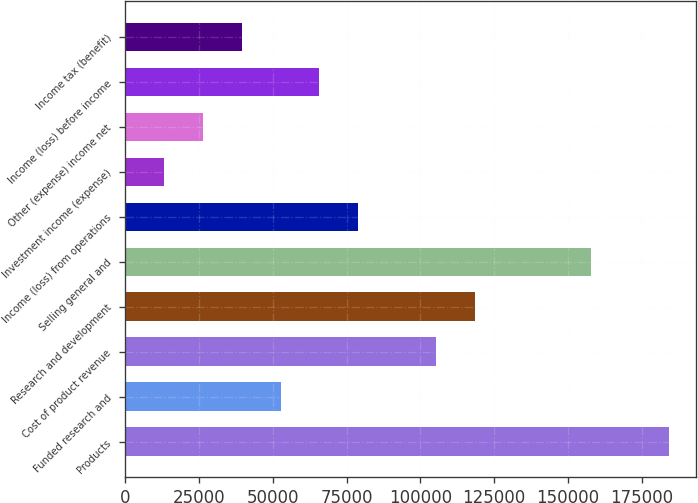Convert chart. <chart><loc_0><loc_0><loc_500><loc_500><bar_chart><fcel>Products<fcel>Funded research and<fcel>Cost of product revenue<fcel>Research and development<fcel>Selling general and<fcel>Income (loss) from operations<fcel>Investment income (expense)<fcel>Other (expense) income net<fcel>Income (loss) before income<fcel>Income tax (benefit)<nl><fcel>184223<fcel>52635.4<fcel>105270<fcel>118429<fcel>157906<fcel>78952.9<fcel>13159.1<fcel>26317.9<fcel>65794.2<fcel>39476.6<nl></chart> 